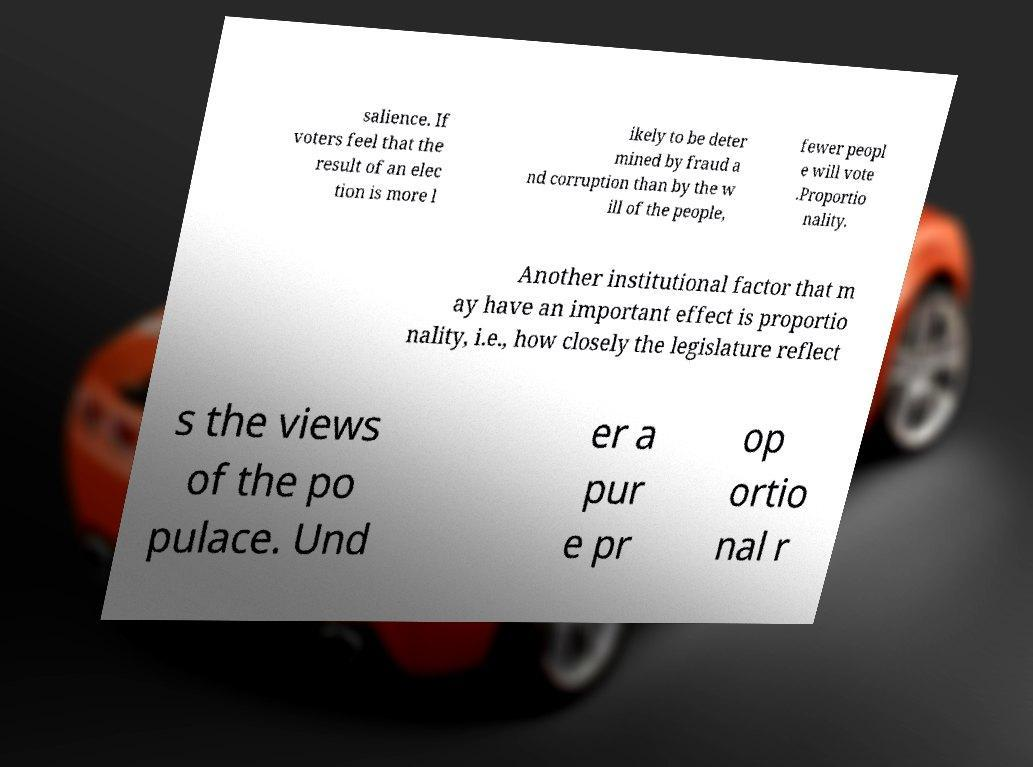Please identify and transcribe the text found in this image. salience. If voters feel that the result of an elec tion is more l ikely to be deter mined by fraud a nd corruption than by the w ill of the people, fewer peopl e will vote .Proportio nality. Another institutional factor that m ay have an important effect is proportio nality, i.e., how closely the legislature reflect s the views of the po pulace. Und er a pur e pr op ortio nal r 